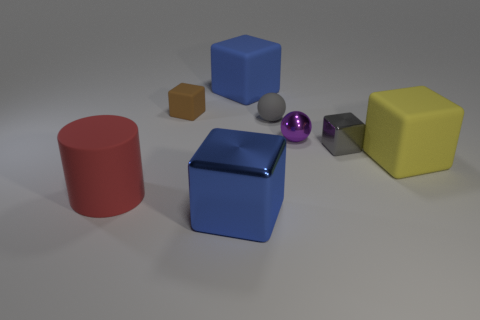There is a blue block that is in front of the purple sphere; does it have the same size as the large red rubber object? The blue block appears to be of a smaller dimension compared to the large red cylindrical object. While the blue block's exact dimensions are not measurable from the image, its scale relative to the other objects suggests that it is not as large. Please note that visual judgments on size can sometimes be misleading without explicit measurements. 